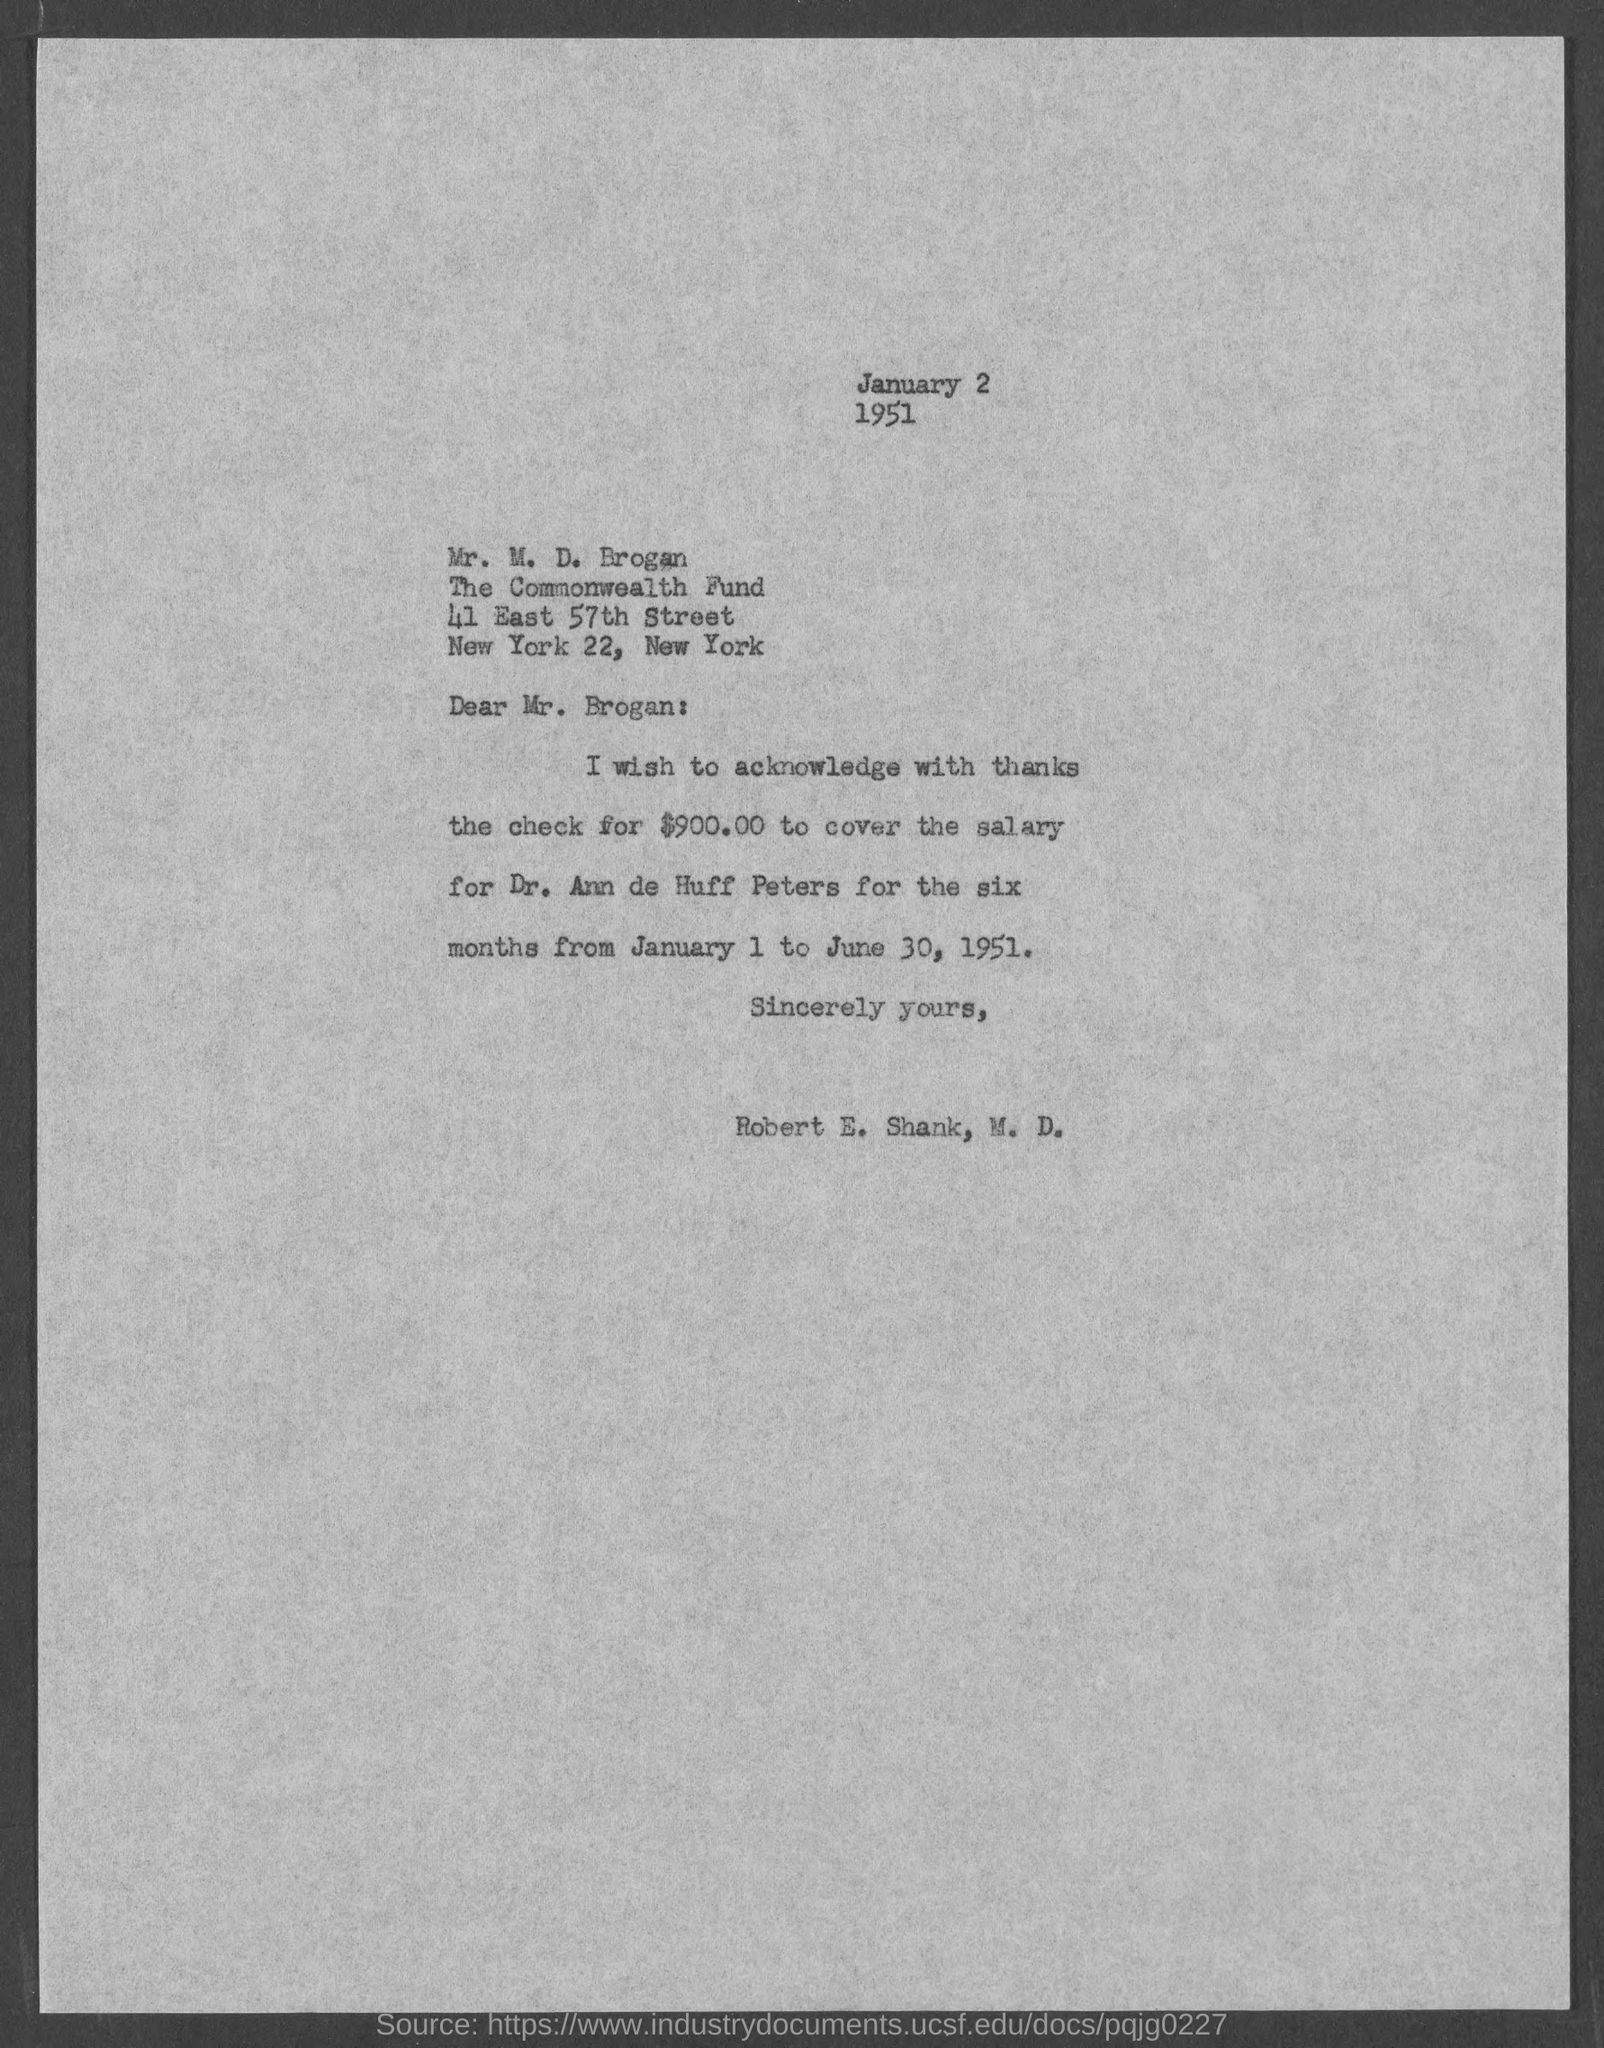What is the issued date of this letter?
Offer a terse response. January 2. What is the check amount as mentioned in the letter?
Offer a terse response. $900.00. Who's salary check is acknowledged in this letter?
Offer a very short reply. Dr. Ann de Huff Peters. 